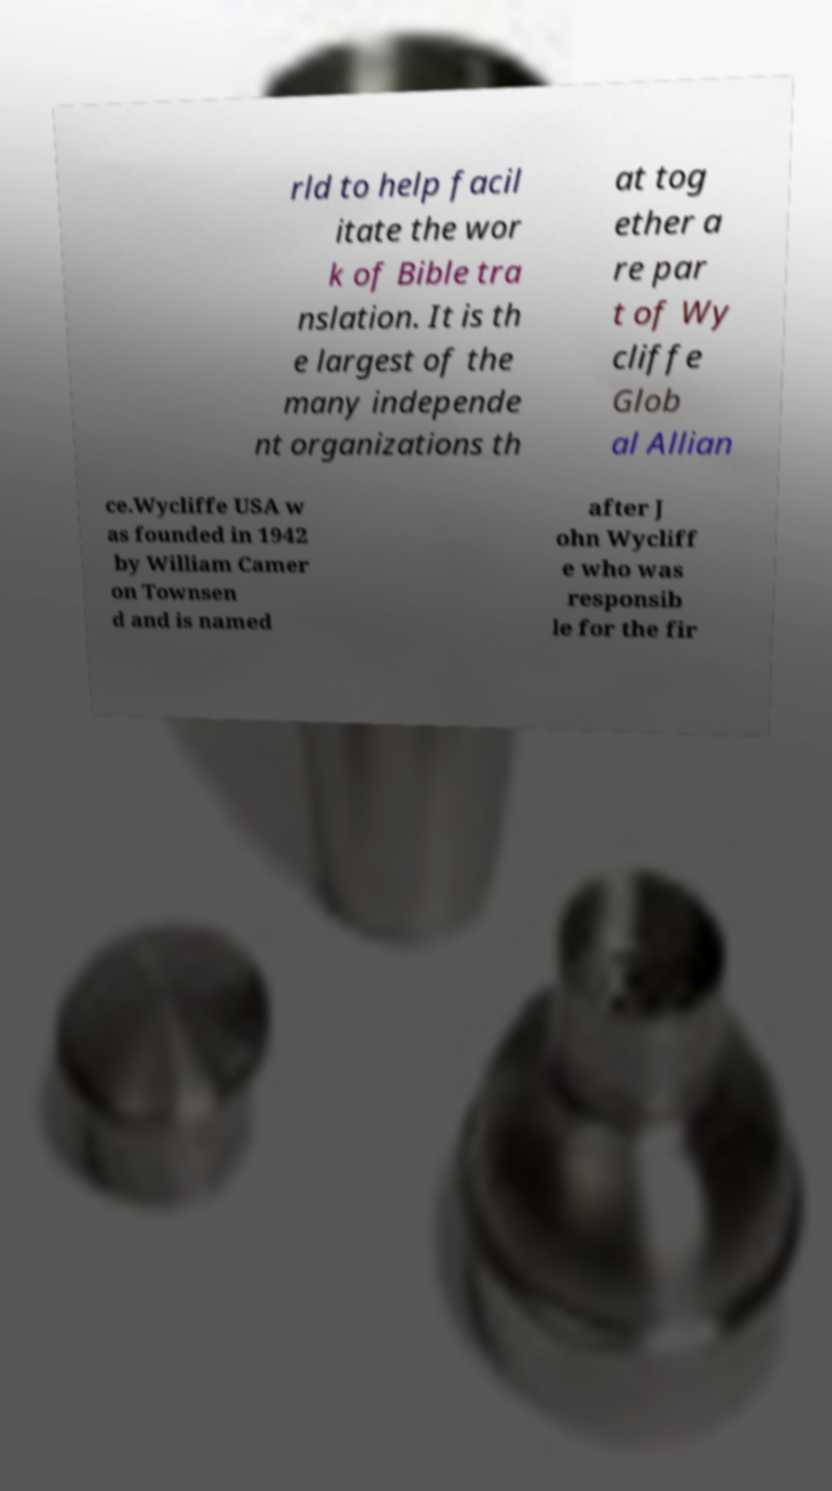I need the written content from this picture converted into text. Can you do that? rld to help facil itate the wor k of Bible tra nslation. It is th e largest of the many independe nt organizations th at tog ether a re par t of Wy cliffe Glob al Allian ce.Wycliffe USA w as founded in 1942 by William Camer on Townsen d and is named after J ohn Wycliff e who was responsib le for the fir 